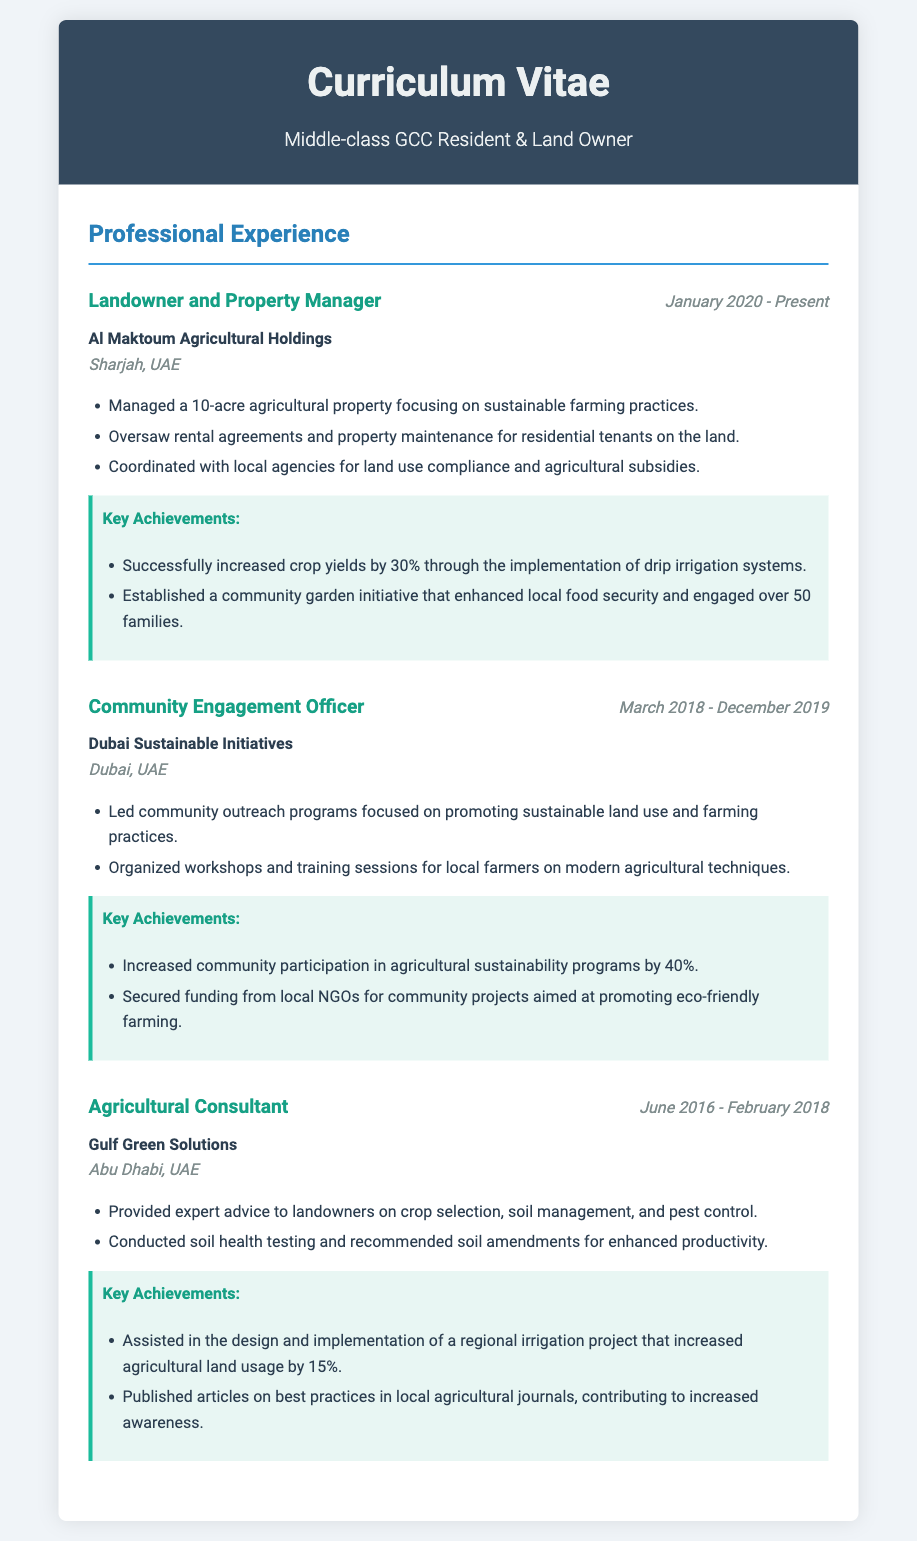What is the current position held? The document states that the current position is "Landowner and Property Manager."
Answer: Landowner and Property Manager Which company employs the Community Engagement Officer? The document mentions the company as "Dubai Sustainable Initiatives."
Answer: Dubai Sustainable Initiatives What agricultural improvement did the Landowner achieve? The document notes an increase in crop yields by 30%.
Answer: 30% Where is the Landowner and Property Manager located? The document specifies the location as "Sharjah, UAE."
Answer: Sharjah, UAE How long did the Agricultural Consultant work at Gulf Green Solutions? The document states the duration from June 2016 to February 2018, totaling approximately 1.5 years.
Answer: June 2016 - February 2018 What community initiative did the Landowner establish? The document highlights the establishment of a "community garden initiative."
Answer: Community garden initiative What was a key role of the Community Engagement Officer? The document describes the role as leading community outreach programs.
Answer: Leading community outreach programs How much did community participation increase during the Community Engagement Officer's tenure? The document indicates a 40% increase in community participation.
Answer: 40% What notable project did the Agricultural Consultant help design? The document mentions a regional irrigation project.
Answer: Regional irrigation project 